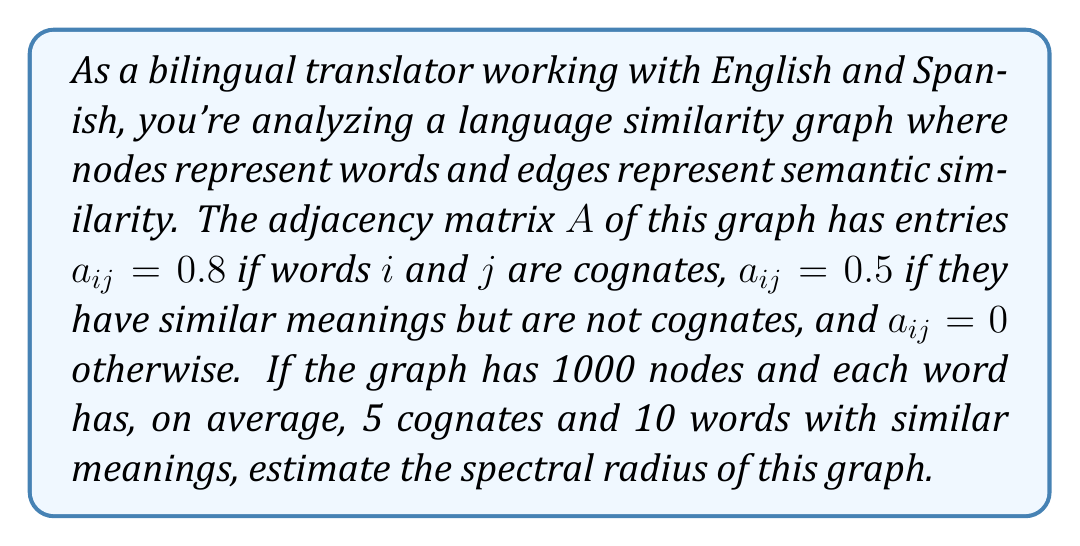Solve this math problem. Let's approach this step-by-step:

1) The spectral radius of a graph is the largest absolute eigenvalue of its adjacency matrix.

2) For large, random matrices, we can estimate the spectral radius using the Perron-Frobenius theorem. This theorem states that for non-negative matrices, the spectral radius is bounded by the minimum and maximum row sums.

3) In our case, all row sums are approximately equal due to the average connectivity given. Let's calculate the average row sum:

   $\text{Average row sum} = (5 \times 0.8) + (10 \times 0.5) + (984 \times 0) = 9$

4) The Perron-Frobenius theorem also tells us that for symmetric matrices (which our adjacency matrix is), the spectral radius is equal to the largest row sum.

5) Therefore, our estimate for the spectral radius is 9.

6) We can improve this estimate using the fact that for large random graphs, the spectral radius is often close to the square root of the maximum degree times the average degree.

7) In our case:
   $\text{Maximum degree} \approx \text{Average degree} = 15$
   
   $\text{Estimated spectral radius} \approx \sqrt{15 \times 15} = 15$

8) This estimate is likely more accurate for our large graph.
Answer: $15$ 